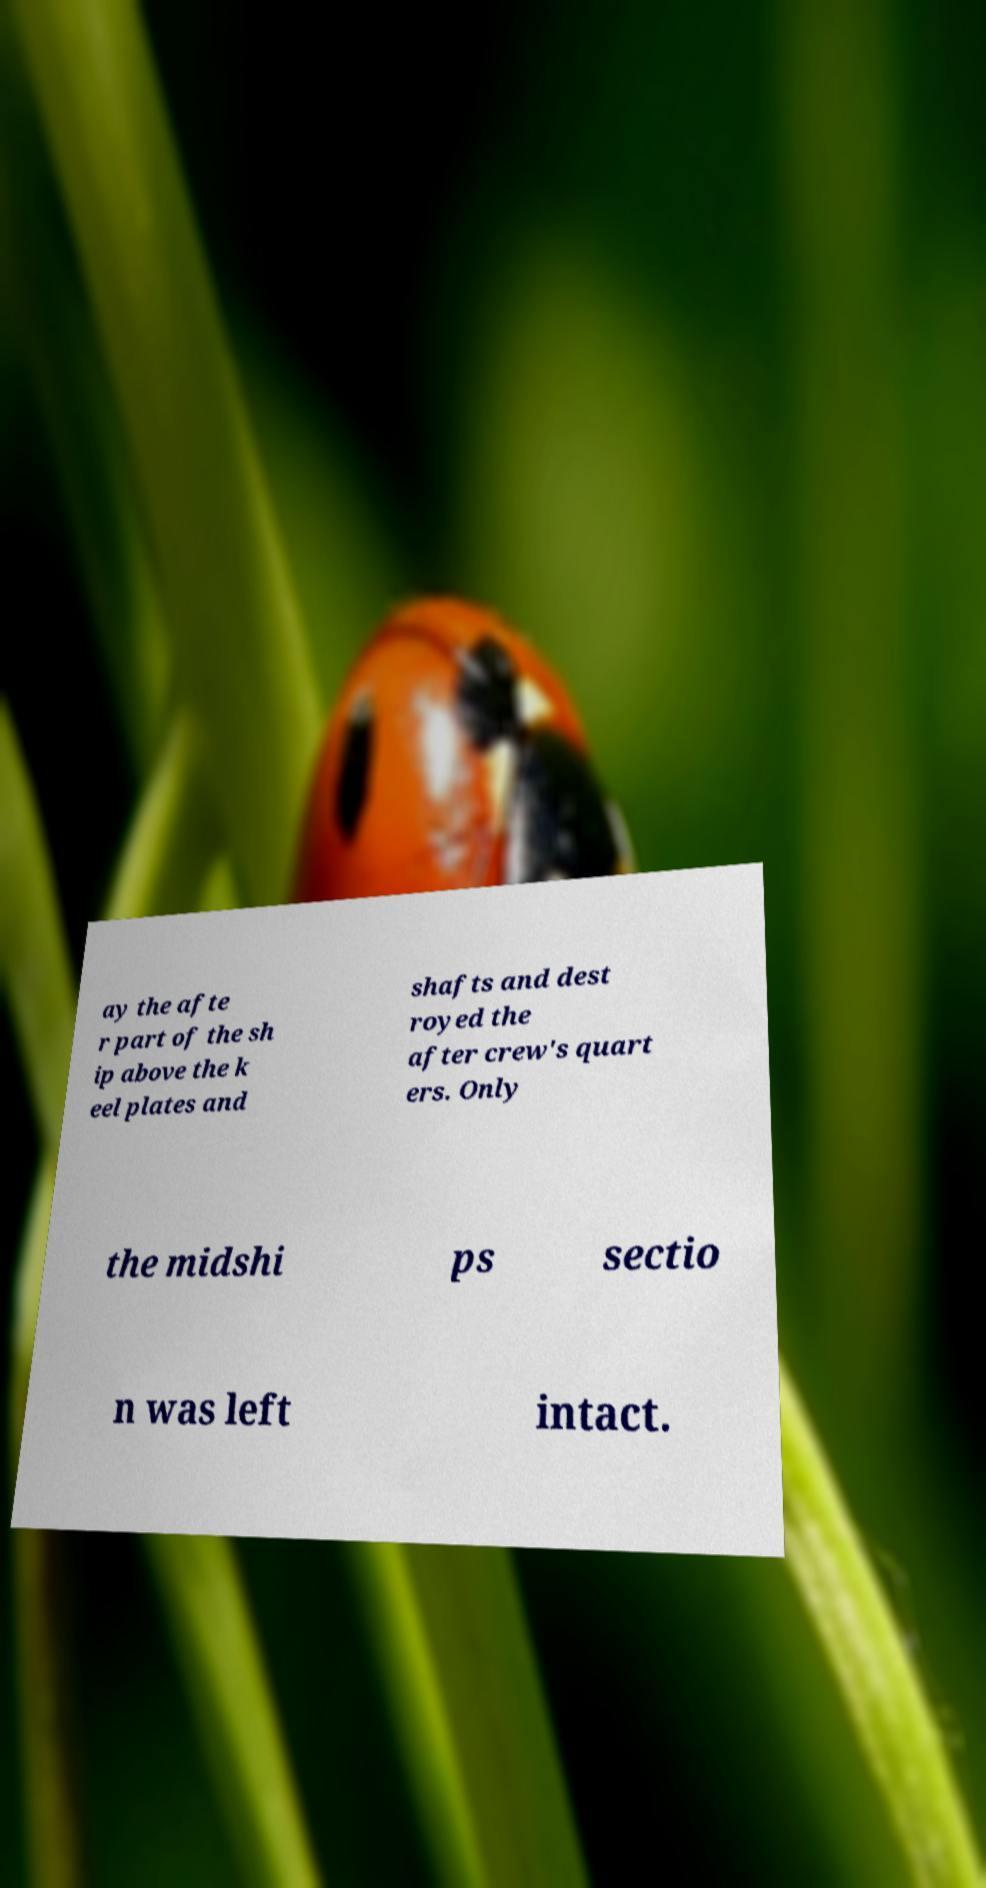Could you extract and type out the text from this image? ay the afte r part of the sh ip above the k eel plates and shafts and dest royed the after crew's quart ers. Only the midshi ps sectio n was left intact. 